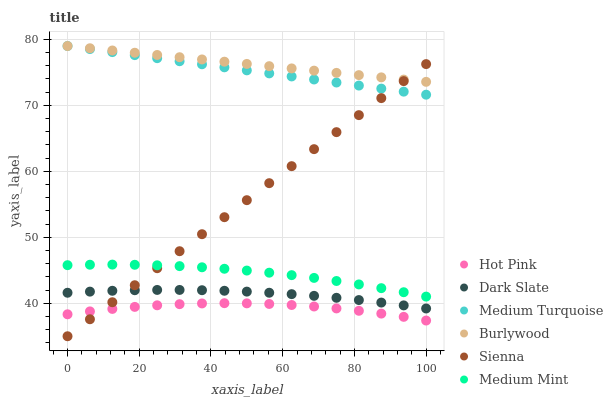Does Hot Pink have the minimum area under the curve?
Answer yes or no. Yes. Does Burlywood have the maximum area under the curve?
Answer yes or no. Yes. Does Burlywood have the minimum area under the curve?
Answer yes or no. No. Does Hot Pink have the maximum area under the curve?
Answer yes or no. No. Is Medium Turquoise the smoothest?
Answer yes or no. Yes. Is Hot Pink the roughest?
Answer yes or no. Yes. Is Burlywood the smoothest?
Answer yes or no. No. Is Burlywood the roughest?
Answer yes or no. No. Does Sienna have the lowest value?
Answer yes or no. Yes. Does Hot Pink have the lowest value?
Answer yes or no. No. Does Medium Turquoise have the highest value?
Answer yes or no. Yes. Does Hot Pink have the highest value?
Answer yes or no. No. Is Hot Pink less than Dark Slate?
Answer yes or no. Yes. Is Burlywood greater than Hot Pink?
Answer yes or no. Yes. Does Medium Mint intersect Sienna?
Answer yes or no. Yes. Is Medium Mint less than Sienna?
Answer yes or no. No. Is Medium Mint greater than Sienna?
Answer yes or no. No. Does Hot Pink intersect Dark Slate?
Answer yes or no. No. 